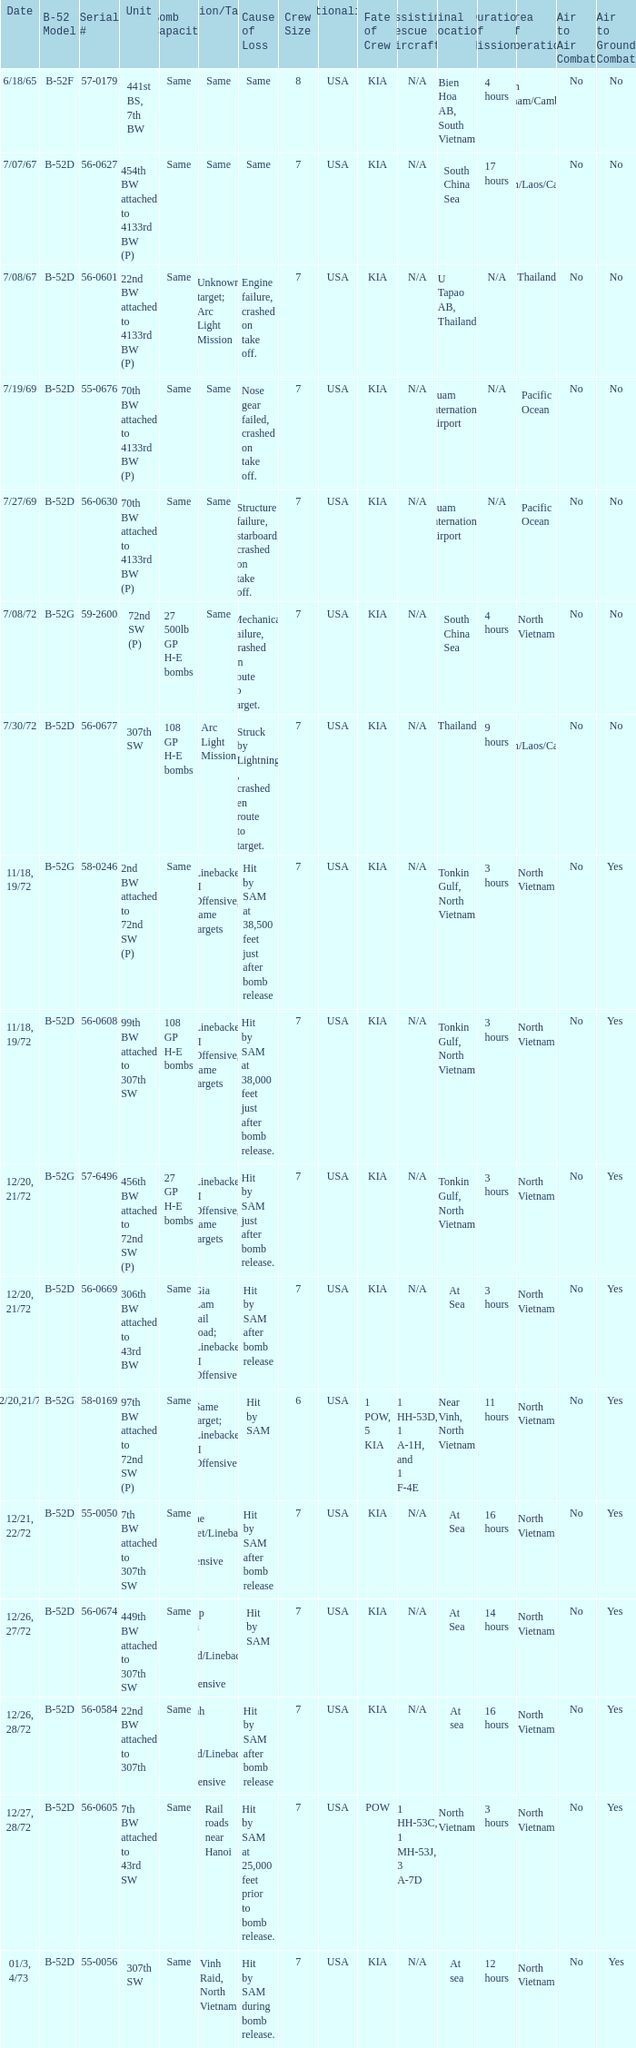When  same target; linebacker ii offensive is the same target what is the unit? 97th BW attached to 72nd SW (P). 